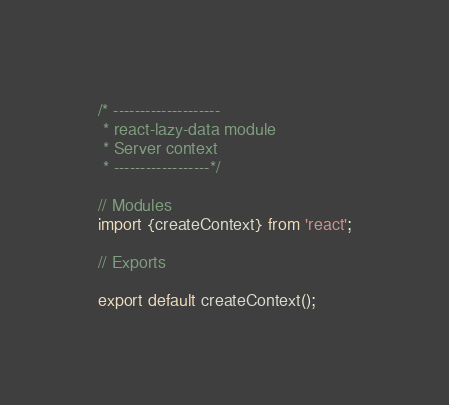Convert code to text. <code><loc_0><loc_0><loc_500><loc_500><_JavaScript_>/* --------------------
 * react-lazy-data module
 * Server context
 * ------------------*/

// Modules
import {createContext} from 'react';

// Exports

export default createContext();
</code> 